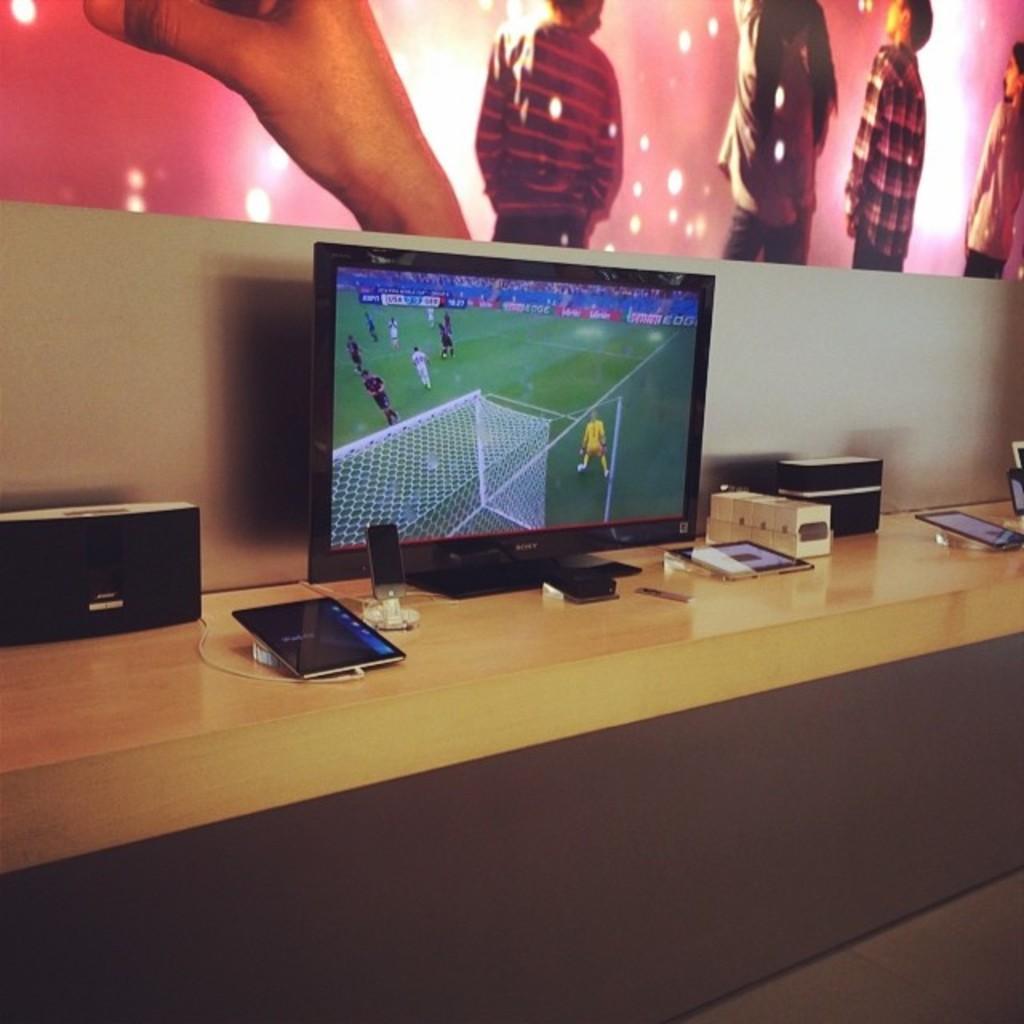Could you give a brief overview of what you see in this image? In this picture I can see electronic devices on the wooden surface. 